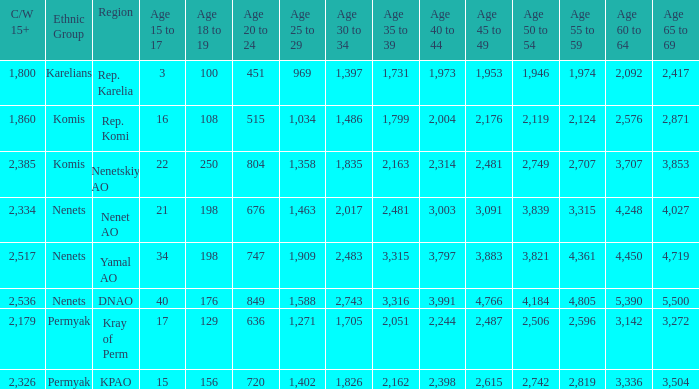Could you parse the entire table? {'header': ['C/W 15+', 'Ethnic Group', 'Region', 'Age 15 to 17', 'Age 18 to 19', 'Age 20 to 24', 'Age 25 to 29', 'Age 30 to 34', 'Age 35 to 39', 'Age 40 to 44', 'Age 45 to 49', 'Age 50 to 54', 'Age 55 to 59', 'Age 60 to 64', 'Age 65 to 69'], 'rows': [['1,800', 'Karelians', 'Rep. Karelia', '3', '100', '451', '969', '1,397', '1,731', '1,973', '1,953', '1,946', '1,974', '2,092', '2,417'], ['1,860', 'Komis', 'Rep. Komi', '16', '108', '515', '1,034', '1,486', '1,799', '2,004', '2,176', '2,119', '2,124', '2,576', '2,871'], ['2,385', 'Komis', 'Nenetskiy AO', '22', '250', '804', '1,358', '1,835', '2,163', '2,314', '2,481', '2,749', '2,707', '3,707', '3,853'], ['2,334', 'Nenets', 'Nenet AO', '21', '198', '676', '1,463', '2,017', '2,481', '3,003', '3,091', '3,839', '3,315', '4,248', '4,027'], ['2,517', 'Nenets', 'Yamal AO', '34', '198', '747', '1,909', '2,483', '3,315', '3,797', '3,883', '3,821', '4,361', '4,450', '4,719'], ['2,536', 'Nenets', 'DNAO', '40', '176', '849', '1,588', '2,743', '3,316', '3,991', '4,766', '4,184', '4,805', '5,390', '5,500'], ['2,179', 'Permyak', 'Kray of Perm', '17', '129', '636', '1,271', '1,705', '2,051', '2,244', '2,487', '2,506', '2,596', '3,142', '3,272'], ['2,326', 'Permyak', 'KPAO', '15', '156', '720', '1,402', '1,826', '2,162', '2,398', '2,615', '2,742', '2,819', '3,336', '3,504']]} What is the total 30 to 34 when the 40 to 44 is greater than 3,003, and the 50 to 54 is greater than 4,184? None. 